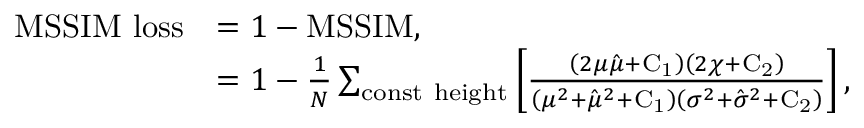<formula> <loc_0><loc_0><loc_500><loc_500>\begin{array} { r l } { M S S I M l o s s } & { = 1 - M S S I M , } \\ & { = 1 - \frac { 1 } { N } \sum _ { c o n s t h e i g h t } \left [ \frac { \left ( 2 \mu \hat { \mu } + C _ { 1 } \right ) \left ( 2 \chi + C _ { 2 } \right ) } { \left ( \mu ^ { 2 } + \hat { \mu } ^ { 2 } + C _ { 1 } \right ) \left ( \sigma ^ { 2 } + \hat { \sigma } ^ { 2 } + C _ { 2 } \right ) } \right ] , } \end{array}</formula> 